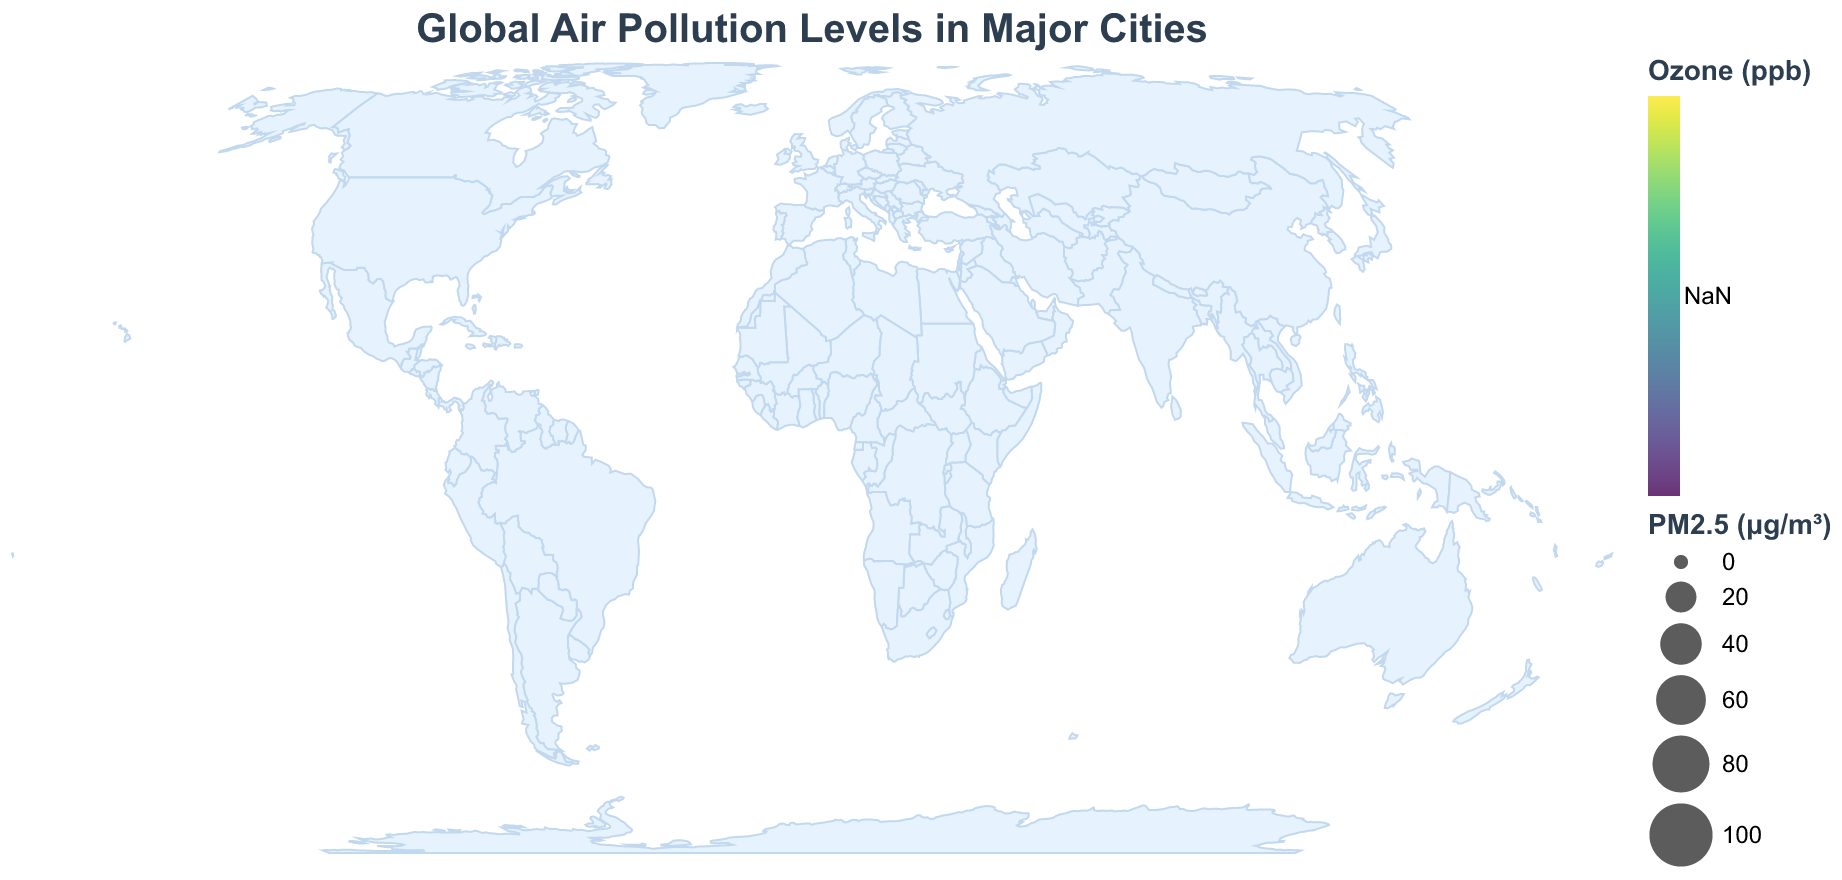What is the title of the figure? The title is placed at the top of the figure and it reads "Global Air Pollution Levels in Major Cities"
Answer: Global Air Pollution Levels in Major Cities How is the PM2.5 level represented on the figure? PM2.5 levels are represented by the size of the circles; larger circles indicate higher PM2.5 concentrations
Answer: Size of circles Which city has the highest PM2.5 level? By observing the size of the circles, the largest circle represents New Delhi, India, with a PM2.5 level of 98.6 μg/m³
Answer: New Delhi Compare the ozone concentrations in Los Angeles and Mexico City. Which one is higher? By looking at the color intensity of the circles, Los Angeles has a higher ozone concentration (87 ppb) than Mexico City (95 ppb)
Answer: Mexico City Which city has the lowest PM2.5 level and what is its value? By identifying the smallest circle, Sydney, Australia, has the lowest PM2.5 level at 7.5 μg/m³
Answer: Sydney, 7.5 μg/m³ How many cities have a PM2.5 level higher than 50 μg/m³? By counting the circles with sizes indicating PM2.5 levels above 50 μg/m³, Beijing, New Delhi, and Cairo fall into this category
Answer: 3 cities What is the relationship between the size of circles and air pollution levels? The size of the circles represents PM2.5 levels, with larger circles indicating higher levels of air pollution
Answer: Larger size -> Higher PM2.5 Find the average PM2.5 concentration across all the cities shown in the figure. Sum the PM2.5 values (58.0 + 98.6 + 11.7 + 15.8 + 73.0 + 11.0 + 13.2 + 20.5 + 10.2 + 7.5) to get 319.5. Then divide by the number of cities (10): 319.5 / 10 = 31.95
Answer: 31.95 μg/m³ Which city has the highest ratio of PM2.5 to Ozone concentration? Explain how you determined this. Calculate the ratio for each city: Beijing (58/62=0.94), New Delhi (98.6/41=2.4), Los Angeles (11.7/87=0.13), São Paulo (15.8/31=0.51), Cairo (73/52=1.4), London (11/38=0.29), Tokyo (13.2/45=0.29), Mexico City (20.5/95=0.22), Moscow (10.2/33=0.31), Sydney (7.5/28=0.27). New Delhi has the highest ratio of 2.4
Answer: New Delhi 